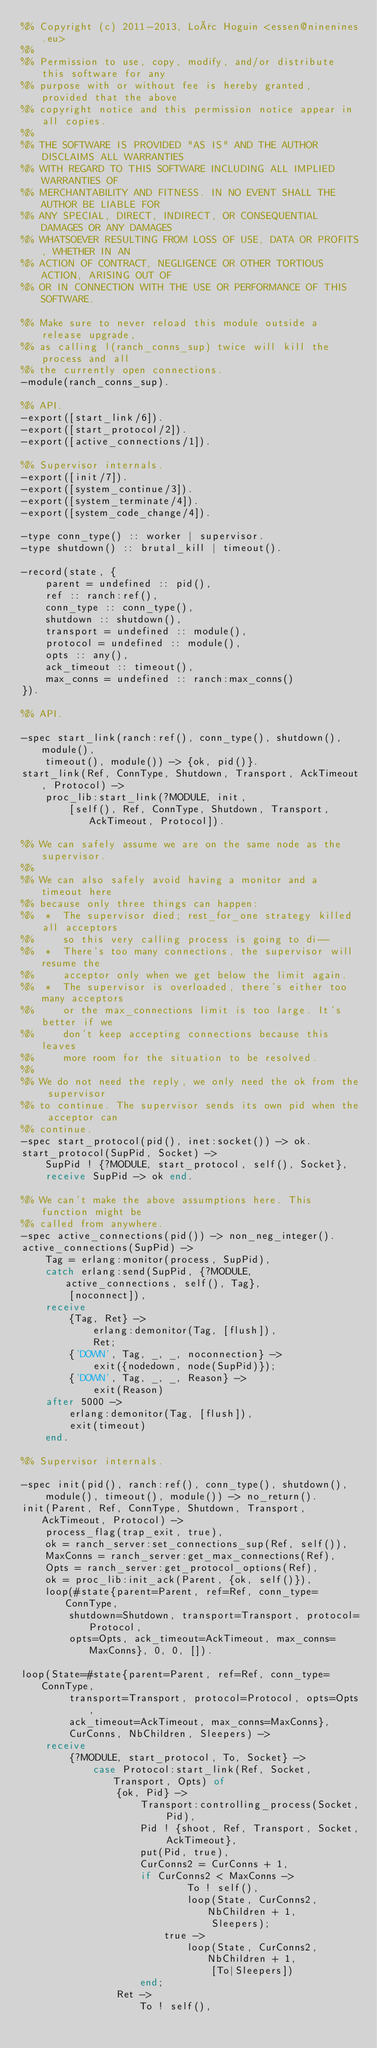<code> <loc_0><loc_0><loc_500><loc_500><_Erlang_>%% Copyright (c) 2011-2013, Loïc Hoguin <essen@ninenines.eu>
%%
%% Permission to use, copy, modify, and/or distribute this software for any
%% purpose with or without fee is hereby granted, provided that the above
%% copyright notice and this permission notice appear in all copies.
%%
%% THE SOFTWARE IS PROVIDED "AS IS" AND THE AUTHOR DISCLAIMS ALL WARRANTIES
%% WITH REGARD TO THIS SOFTWARE INCLUDING ALL IMPLIED WARRANTIES OF
%% MERCHANTABILITY AND FITNESS. IN NO EVENT SHALL THE AUTHOR BE LIABLE FOR
%% ANY SPECIAL, DIRECT, INDIRECT, OR CONSEQUENTIAL DAMAGES OR ANY DAMAGES
%% WHATSOEVER RESULTING FROM LOSS OF USE, DATA OR PROFITS, WHETHER IN AN
%% ACTION OF CONTRACT, NEGLIGENCE OR OTHER TORTIOUS ACTION, ARISING OUT OF
%% OR IN CONNECTION WITH THE USE OR PERFORMANCE OF THIS SOFTWARE.

%% Make sure to never reload this module outside a release upgrade,
%% as calling l(ranch_conns_sup) twice will kill the process and all
%% the currently open connections.
-module(ranch_conns_sup).

%% API.
-export([start_link/6]).
-export([start_protocol/2]).
-export([active_connections/1]).

%% Supervisor internals.
-export([init/7]).
-export([system_continue/3]).
-export([system_terminate/4]).
-export([system_code_change/4]).

-type conn_type() :: worker | supervisor.
-type shutdown() :: brutal_kill | timeout().

-record(state, {
	parent = undefined :: pid(),
	ref :: ranch:ref(),
	conn_type :: conn_type(),
	shutdown :: shutdown(),
	transport = undefined :: module(),
	protocol = undefined :: module(),
	opts :: any(),
	ack_timeout :: timeout(),
	max_conns = undefined :: ranch:max_conns()
}).

%% API.

-spec start_link(ranch:ref(), conn_type(), shutdown(), module(),
	timeout(), module()) -> {ok, pid()}.
start_link(Ref, ConnType, Shutdown, Transport, AckTimeout, Protocol) ->
	proc_lib:start_link(?MODULE, init,
		[self(), Ref, ConnType, Shutdown, Transport, AckTimeout, Protocol]).

%% We can safely assume we are on the same node as the supervisor.
%%
%% We can also safely avoid having a monitor and a timeout here
%% because only three things can happen:
%%  *  The supervisor died; rest_for_one strategy killed all acceptors
%%     so this very calling process is going to di--
%%  *  There's too many connections, the supervisor will resume the
%%     acceptor only when we get below the limit again.
%%  *  The supervisor is overloaded, there's either too many acceptors
%%     or the max_connections limit is too large. It's better if we
%%     don't keep accepting connections because this leaves
%%     more room for the situation to be resolved.
%%
%% We do not need the reply, we only need the ok from the supervisor
%% to continue. The supervisor sends its own pid when the acceptor can
%% continue.
-spec start_protocol(pid(), inet:socket()) -> ok.
start_protocol(SupPid, Socket) ->
	SupPid ! {?MODULE, start_protocol, self(), Socket},
	receive SupPid -> ok end.

%% We can't make the above assumptions here. This function might be
%% called from anywhere.
-spec active_connections(pid()) -> non_neg_integer().
active_connections(SupPid) ->
	Tag = erlang:monitor(process, SupPid),
	catch erlang:send(SupPid, {?MODULE, active_connections, self(), Tag},
		[noconnect]),
	receive
		{Tag, Ret} ->
			erlang:demonitor(Tag, [flush]),
			Ret;
		{'DOWN', Tag, _, _, noconnection} ->
			exit({nodedown, node(SupPid)});
		{'DOWN', Tag, _, _, Reason} ->
			exit(Reason)
	after 5000 ->
		erlang:demonitor(Tag, [flush]),
		exit(timeout)
	end.

%% Supervisor internals.

-spec init(pid(), ranch:ref(), conn_type(), shutdown(),
	module(), timeout(), module()) -> no_return().
init(Parent, Ref, ConnType, Shutdown, Transport, AckTimeout, Protocol) ->
	process_flag(trap_exit, true),
	ok = ranch_server:set_connections_sup(Ref, self()),
	MaxConns = ranch_server:get_max_connections(Ref),
	Opts = ranch_server:get_protocol_options(Ref),
	ok = proc_lib:init_ack(Parent, {ok, self()}),
	loop(#state{parent=Parent, ref=Ref, conn_type=ConnType,
		shutdown=Shutdown, transport=Transport, protocol=Protocol,
		opts=Opts, ack_timeout=AckTimeout, max_conns=MaxConns}, 0, 0, []).

loop(State=#state{parent=Parent, ref=Ref, conn_type=ConnType,
		transport=Transport, protocol=Protocol, opts=Opts,
		ack_timeout=AckTimeout, max_conns=MaxConns},
		CurConns, NbChildren, Sleepers) ->
	receive
		{?MODULE, start_protocol, To, Socket} ->
			case Protocol:start_link(Ref, Socket, Transport, Opts) of
				{ok, Pid} ->
					Transport:controlling_process(Socket, Pid),
					Pid ! {shoot, Ref, Transport, Socket, AckTimeout},
					put(Pid, true),
					CurConns2 = CurConns + 1,
					if CurConns2 < MaxConns ->
							To ! self(),
							loop(State, CurConns2, NbChildren + 1,
								Sleepers);
						true ->
							loop(State, CurConns2, NbChildren + 1,
								[To|Sleepers])
					end;
				Ret ->
					To ! self(),</code> 